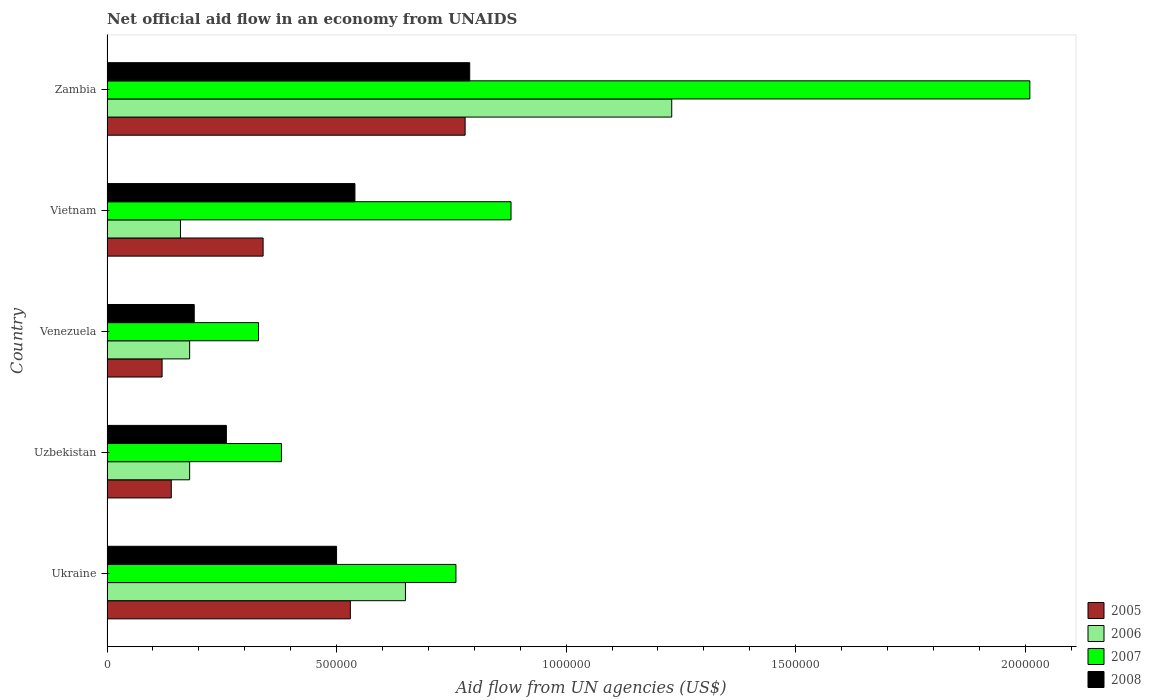How many different coloured bars are there?
Your answer should be very brief. 4. How many bars are there on the 1st tick from the top?
Offer a terse response. 4. How many bars are there on the 4th tick from the bottom?
Offer a terse response. 4. What is the label of the 3rd group of bars from the top?
Your response must be concise. Venezuela. In how many cases, is the number of bars for a given country not equal to the number of legend labels?
Your response must be concise. 0. Across all countries, what is the maximum net official aid flow in 2006?
Provide a succinct answer. 1.23e+06. Across all countries, what is the minimum net official aid flow in 2007?
Provide a short and direct response. 3.30e+05. In which country was the net official aid flow in 2007 maximum?
Make the answer very short. Zambia. In which country was the net official aid flow in 2005 minimum?
Your answer should be compact. Venezuela. What is the total net official aid flow in 2006 in the graph?
Offer a very short reply. 2.40e+06. What is the difference between the net official aid flow in 2008 in Uzbekistan and that in Venezuela?
Your answer should be compact. 7.00e+04. What is the difference between the net official aid flow in 2006 in Zambia and the net official aid flow in 2005 in Vietnam?
Your answer should be compact. 8.90e+05. What is the average net official aid flow in 2007 per country?
Ensure brevity in your answer.  8.72e+05. What is the difference between the net official aid flow in 2006 and net official aid flow in 2008 in Venezuela?
Offer a very short reply. -10000. What is the ratio of the net official aid flow in 2005 in Uzbekistan to that in Venezuela?
Your answer should be very brief. 1.17. Is the net official aid flow in 2005 in Venezuela less than that in Vietnam?
Ensure brevity in your answer.  Yes. What is the difference between the highest and the second highest net official aid flow in 2005?
Your answer should be very brief. 2.50e+05. What is the difference between the highest and the lowest net official aid flow in 2006?
Your answer should be compact. 1.07e+06. Is it the case that in every country, the sum of the net official aid flow in 2005 and net official aid flow in 2008 is greater than the sum of net official aid flow in 2006 and net official aid flow in 2007?
Your response must be concise. No. What does the 2nd bar from the bottom in Venezuela represents?
Keep it short and to the point. 2006. Is it the case that in every country, the sum of the net official aid flow in 2007 and net official aid flow in 2008 is greater than the net official aid flow in 2006?
Keep it short and to the point. Yes. Are all the bars in the graph horizontal?
Provide a succinct answer. Yes. How many countries are there in the graph?
Keep it short and to the point. 5. Are the values on the major ticks of X-axis written in scientific E-notation?
Make the answer very short. No. Where does the legend appear in the graph?
Make the answer very short. Bottom right. How many legend labels are there?
Your response must be concise. 4. How are the legend labels stacked?
Keep it short and to the point. Vertical. What is the title of the graph?
Ensure brevity in your answer.  Net official aid flow in an economy from UNAIDS. What is the label or title of the X-axis?
Keep it short and to the point. Aid flow from UN agencies (US$). What is the label or title of the Y-axis?
Keep it short and to the point. Country. What is the Aid flow from UN agencies (US$) of 2005 in Ukraine?
Your answer should be very brief. 5.30e+05. What is the Aid flow from UN agencies (US$) of 2006 in Ukraine?
Ensure brevity in your answer.  6.50e+05. What is the Aid flow from UN agencies (US$) of 2007 in Ukraine?
Give a very brief answer. 7.60e+05. What is the Aid flow from UN agencies (US$) in 2008 in Ukraine?
Provide a short and direct response. 5.00e+05. What is the Aid flow from UN agencies (US$) of 2005 in Uzbekistan?
Keep it short and to the point. 1.40e+05. What is the Aid flow from UN agencies (US$) of 2006 in Uzbekistan?
Provide a short and direct response. 1.80e+05. What is the Aid flow from UN agencies (US$) of 2008 in Uzbekistan?
Provide a succinct answer. 2.60e+05. What is the Aid flow from UN agencies (US$) in 2008 in Venezuela?
Provide a short and direct response. 1.90e+05. What is the Aid flow from UN agencies (US$) in 2007 in Vietnam?
Provide a short and direct response. 8.80e+05. What is the Aid flow from UN agencies (US$) in 2008 in Vietnam?
Give a very brief answer. 5.40e+05. What is the Aid flow from UN agencies (US$) of 2005 in Zambia?
Your answer should be very brief. 7.80e+05. What is the Aid flow from UN agencies (US$) in 2006 in Zambia?
Your answer should be compact. 1.23e+06. What is the Aid flow from UN agencies (US$) of 2007 in Zambia?
Keep it short and to the point. 2.01e+06. What is the Aid flow from UN agencies (US$) in 2008 in Zambia?
Your answer should be very brief. 7.90e+05. Across all countries, what is the maximum Aid flow from UN agencies (US$) in 2005?
Offer a very short reply. 7.80e+05. Across all countries, what is the maximum Aid flow from UN agencies (US$) of 2006?
Offer a very short reply. 1.23e+06. Across all countries, what is the maximum Aid flow from UN agencies (US$) of 2007?
Provide a short and direct response. 2.01e+06. Across all countries, what is the maximum Aid flow from UN agencies (US$) of 2008?
Offer a very short reply. 7.90e+05. Across all countries, what is the minimum Aid flow from UN agencies (US$) of 2005?
Make the answer very short. 1.20e+05. Across all countries, what is the minimum Aid flow from UN agencies (US$) of 2006?
Offer a terse response. 1.60e+05. Across all countries, what is the minimum Aid flow from UN agencies (US$) in 2007?
Give a very brief answer. 3.30e+05. Across all countries, what is the minimum Aid flow from UN agencies (US$) of 2008?
Your answer should be very brief. 1.90e+05. What is the total Aid flow from UN agencies (US$) in 2005 in the graph?
Your response must be concise. 1.91e+06. What is the total Aid flow from UN agencies (US$) of 2006 in the graph?
Provide a succinct answer. 2.40e+06. What is the total Aid flow from UN agencies (US$) in 2007 in the graph?
Make the answer very short. 4.36e+06. What is the total Aid flow from UN agencies (US$) of 2008 in the graph?
Offer a very short reply. 2.28e+06. What is the difference between the Aid flow from UN agencies (US$) in 2005 in Ukraine and that in Uzbekistan?
Your answer should be very brief. 3.90e+05. What is the difference between the Aid flow from UN agencies (US$) of 2006 in Ukraine and that in Uzbekistan?
Provide a succinct answer. 4.70e+05. What is the difference between the Aid flow from UN agencies (US$) of 2008 in Ukraine and that in Uzbekistan?
Your answer should be very brief. 2.40e+05. What is the difference between the Aid flow from UN agencies (US$) in 2005 in Ukraine and that in Venezuela?
Your answer should be compact. 4.10e+05. What is the difference between the Aid flow from UN agencies (US$) of 2008 in Ukraine and that in Venezuela?
Provide a short and direct response. 3.10e+05. What is the difference between the Aid flow from UN agencies (US$) in 2005 in Ukraine and that in Zambia?
Your answer should be very brief. -2.50e+05. What is the difference between the Aid flow from UN agencies (US$) in 2006 in Ukraine and that in Zambia?
Provide a succinct answer. -5.80e+05. What is the difference between the Aid flow from UN agencies (US$) in 2007 in Ukraine and that in Zambia?
Keep it short and to the point. -1.25e+06. What is the difference between the Aid flow from UN agencies (US$) of 2008 in Ukraine and that in Zambia?
Offer a terse response. -2.90e+05. What is the difference between the Aid flow from UN agencies (US$) in 2006 in Uzbekistan and that in Venezuela?
Offer a terse response. 0. What is the difference between the Aid flow from UN agencies (US$) in 2007 in Uzbekistan and that in Venezuela?
Ensure brevity in your answer.  5.00e+04. What is the difference between the Aid flow from UN agencies (US$) of 2006 in Uzbekistan and that in Vietnam?
Give a very brief answer. 2.00e+04. What is the difference between the Aid flow from UN agencies (US$) in 2007 in Uzbekistan and that in Vietnam?
Provide a succinct answer. -5.00e+05. What is the difference between the Aid flow from UN agencies (US$) in 2008 in Uzbekistan and that in Vietnam?
Your response must be concise. -2.80e+05. What is the difference between the Aid flow from UN agencies (US$) of 2005 in Uzbekistan and that in Zambia?
Give a very brief answer. -6.40e+05. What is the difference between the Aid flow from UN agencies (US$) of 2006 in Uzbekistan and that in Zambia?
Offer a very short reply. -1.05e+06. What is the difference between the Aid flow from UN agencies (US$) in 2007 in Uzbekistan and that in Zambia?
Keep it short and to the point. -1.63e+06. What is the difference between the Aid flow from UN agencies (US$) of 2008 in Uzbekistan and that in Zambia?
Make the answer very short. -5.30e+05. What is the difference between the Aid flow from UN agencies (US$) of 2006 in Venezuela and that in Vietnam?
Make the answer very short. 2.00e+04. What is the difference between the Aid flow from UN agencies (US$) of 2007 in Venezuela and that in Vietnam?
Give a very brief answer. -5.50e+05. What is the difference between the Aid flow from UN agencies (US$) of 2008 in Venezuela and that in Vietnam?
Ensure brevity in your answer.  -3.50e+05. What is the difference between the Aid flow from UN agencies (US$) of 2005 in Venezuela and that in Zambia?
Make the answer very short. -6.60e+05. What is the difference between the Aid flow from UN agencies (US$) in 2006 in Venezuela and that in Zambia?
Your answer should be very brief. -1.05e+06. What is the difference between the Aid flow from UN agencies (US$) in 2007 in Venezuela and that in Zambia?
Your answer should be very brief. -1.68e+06. What is the difference between the Aid flow from UN agencies (US$) of 2008 in Venezuela and that in Zambia?
Your response must be concise. -6.00e+05. What is the difference between the Aid flow from UN agencies (US$) in 2005 in Vietnam and that in Zambia?
Your response must be concise. -4.40e+05. What is the difference between the Aid flow from UN agencies (US$) of 2006 in Vietnam and that in Zambia?
Make the answer very short. -1.07e+06. What is the difference between the Aid flow from UN agencies (US$) in 2007 in Vietnam and that in Zambia?
Provide a short and direct response. -1.13e+06. What is the difference between the Aid flow from UN agencies (US$) in 2005 in Ukraine and the Aid flow from UN agencies (US$) in 2008 in Uzbekistan?
Offer a very short reply. 2.70e+05. What is the difference between the Aid flow from UN agencies (US$) of 2007 in Ukraine and the Aid flow from UN agencies (US$) of 2008 in Uzbekistan?
Offer a terse response. 5.00e+05. What is the difference between the Aid flow from UN agencies (US$) in 2005 in Ukraine and the Aid flow from UN agencies (US$) in 2007 in Venezuela?
Give a very brief answer. 2.00e+05. What is the difference between the Aid flow from UN agencies (US$) in 2006 in Ukraine and the Aid flow from UN agencies (US$) in 2008 in Venezuela?
Provide a short and direct response. 4.60e+05. What is the difference between the Aid flow from UN agencies (US$) in 2007 in Ukraine and the Aid flow from UN agencies (US$) in 2008 in Venezuela?
Offer a terse response. 5.70e+05. What is the difference between the Aid flow from UN agencies (US$) in 2005 in Ukraine and the Aid flow from UN agencies (US$) in 2006 in Vietnam?
Provide a succinct answer. 3.70e+05. What is the difference between the Aid flow from UN agencies (US$) in 2005 in Ukraine and the Aid flow from UN agencies (US$) in 2007 in Vietnam?
Make the answer very short. -3.50e+05. What is the difference between the Aid flow from UN agencies (US$) of 2006 in Ukraine and the Aid flow from UN agencies (US$) of 2008 in Vietnam?
Offer a terse response. 1.10e+05. What is the difference between the Aid flow from UN agencies (US$) in 2005 in Ukraine and the Aid flow from UN agencies (US$) in 2006 in Zambia?
Ensure brevity in your answer.  -7.00e+05. What is the difference between the Aid flow from UN agencies (US$) in 2005 in Ukraine and the Aid flow from UN agencies (US$) in 2007 in Zambia?
Offer a very short reply. -1.48e+06. What is the difference between the Aid flow from UN agencies (US$) in 2006 in Ukraine and the Aid flow from UN agencies (US$) in 2007 in Zambia?
Offer a terse response. -1.36e+06. What is the difference between the Aid flow from UN agencies (US$) of 2007 in Ukraine and the Aid flow from UN agencies (US$) of 2008 in Zambia?
Offer a terse response. -3.00e+04. What is the difference between the Aid flow from UN agencies (US$) in 2005 in Uzbekistan and the Aid flow from UN agencies (US$) in 2006 in Venezuela?
Your response must be concise. -4.00e+04. What is the difference between the Aid flow from UN agencies (US$) in 2006 in Uzbekistan and the Aid flow from UN agencies (US$) in 2007 in Venezuela?
Provide a succinct answer. -1.50e+05. What is the difference between the Aid flow from UN agencies (US$) of 2007 in Uzbekistan and the Aid flow from UN agencies (US$) of 2008 in Venezuela?
Your answer should be compact. 1.90e+05. What is the difference between the Aid flow from UN agencies (US$) of 2005 in Uzbekistan and the Aid flow from UN agencies (US$) of 2006 in Vietnam?
Your response must be concise. -2.00e+04. What is the difference between the Aid flow from UN agencies (US$) of 2005 in Uzbekistan and the Aid flow from UN agencies (US$) of 2007 in Vietnam?
Provide a short and direct response. -7.40e+05. What is the difference between the Aid flow from UN agencies (US$) of 2005 in Uzbekistan and the Aid flow from UN agencies (US$) of 2008 in Vietnam?
Ensure brevity in your answer.  -4.00e+05. What is the difference between the Aid flow from UN agencies (US$) in 2006 in Uzbekistan and the Aid flow from UN agencies (US$) in 2007 in Vietnam?
Your answer should be compact. -7.00e+05. What is the difference between the Aid flow from UN agencies (US$) of 2006 in Uzbekistan and the Aid flow from UN agencies (US$) of 2008 in Vietnam?
Ensure brevity in your answer.  -3.60e+05. What is the difference between the Aid flow from UN agencies (US$) of 2005 in Uzbekistan and the Aid flow from UN agencies (US$) of 2006 in Zambia?
Your response must be concise. -1.09e+06. What is the difference between the Aid flow from UN agencies (US$) of 2005 in Uzbekistan and the Aid flow from UN agencies (US$) of 2007 in Zambia?
Keep it short and to the point. -1.87e+06. What is the difference between the Aid flow from UN agencies (US$) of 2005 in Uzbekistan and the Aid flow from UN agencies (US$) of 2008 in Zambia?
Your response must be concise. -6.50e+05. What is the difference between the Aid flow from UN agencies (US$) of 2006 in Uzbekistan and the Aid flow from UN agencies (US$) of 2007 in Zambia?
Your response must be concise. -1.83e+06. What is the difference between the Aid flow from UN agencies (US$) of 2006 in Uzbekistan and the Aid flow from UN agencies (US$) of 2008 in Zambia?
Your answer should be very brief. -6.10e+05. What is the difference between the Aid flow from UN agencies (US$) in 2007 in Uzbekistan and the Aid flow from UN agencies (US$) in 2008 in Zambia?
Your answer should be very brief. -4.10e+05. What is the difference between the Aid flow from UN agencies (US$) in 2005 in Venezuela and the Aid flow from UN agencies (US$) in 2006 in Vietnam?
Your response must be concise. -4.00e+04. What is the difference between the Aid flow from UN agencies (US$) of 2005 in Venezuela and the Aid flow from UN agencies (US$) of 2007 in Vietnam?
Keep it short and to the point. -7.60e+05. What is the difference between the Aid flow from UN agencies (US$) in 2005 in Venezuela and the Aid flow from UN agencies (US$) in 2008 in Vietnam?
Your answer should be very brief. -4.20e+05. What is the difference between the Aid flow from UN agencies (US$) of 2006 in Venezuela and the Aid flow from UN agencies (US$) of 2007 in Vietnam?
Give a very brief answer. -7.00e+05. What is the difference between the Aid flow from UN agencies (US$) in 2006 in Venezuela and the Aid flow from UN agencies (US$) in 2008 in Vietnam?
Your response must be concise. -3.60e+05. What is the difference between the Aid flow from UN agencies (US$) in 2007 in Venezuela and the Aid flow from UN agencies (US$) in 2008 in Vietnam?
Provide a short and direct response. -2.10e+05. What is the difference between the Aid flow from UN agencies (US$) in 2005 in Venezuela and the Aid flow from UN agencies (US$) in 2006 in Zambia?
Offer a very short reply. -1.11e+06. What is the difference between the Aid flow from UN agencies (US$) in 2005 in Venezuela and the Aid flow from UN agencies (US$) in 2007 in Zambia?
Keep it short and to the point. -1.89e+06. What is the difference between the Aid flow from UN agencies (US$) of 2005 in Venezuela and the Aid flow from UN agencies (US$) of 2008 in Zambia?
Offer a terse response. -6.70e+05. What is the difference between the Aid flow from UN agencies (US$) of 2006 in Venezuela and the Aid flow from UN agencies (US$) of 2007 in Zambia?
Keep it short and to the point. -1.83e+06. What is the difference between the Aid flow from UN agencies (US$) of 2006 in Venezuela and the Aid flow from UN agencies (US$) of 2008 in Zambia?
Your answer should be compact. -6.10e+05. What is the difference between the Aid flow from UN agencies (US$) of 2007 in Venezuela and the Aid flow from UN agencies (US$) of 2008 in Zambia?
Ensure brevity in your answer.  -4.60e+05. What is the difference between the Aid flow from UN agencies (US$) of 2005 in Vietnam and the Aid flow from UN agencies (US$) of 2006 in Zambia?
Your response must be concise. -8.90e+05. What is the difference between the Aid flow from UN agencies (US$) in 2005 in Vietnam and the Aid flow from UN agencies (US$) in 2007 in Zambia?
Your response must be concise. -1.67e+06. What is the difference between the Aid flow from UN agencies (US$) of 2005 in Vietnam and the Aid flow from UN agencies (US$) of 2008 in Zambia?
Give a very brief answer. -4.50e+05. What is the difference between the Aid flow from UN agencies (US$) of 2006 in Vietnam and the Aid flow from UN agencies (US$) of 2007 in Zambia?
Provide a succinct answer. -1.85e+06. What is the difference between the Aid flow from UN agencies (US$) in 2006 in Vietnam and the Aid flow from UN agencies (US$) in 2008 in Zambia?
Give a very brief answer. -6.30e+05. What is the average Aid flow from UN agencies (US$) of 2005 per country?
Keep it short and to the point. 3.82e+05. What is the average Aid flow from UN agencies (US$) of 2006 per country?
Offer a very short reply. 4.80e+05. What is the average Aid flow from UN agencies (US$) of 2007 per country?
Keep it short and to the point. 8.72e+05. What is the average Aid flow from UN agencies (US$) in 2008 per country?
Your answer should be compact. 4.56e+05. What is the difference between the Aid flow from UN agencies (US$) in 2006 and Aid flow from UN agencies (US$) in 2007 in Ukraine?
Your answer should be compact. -1.10e+05. What is the difference between the Aid flow from UN agencies (US$) in 2006 and Aid flow from UN agencies (US$) in 2008 in Ukraine?
Provide a succinct answer. 1.50e+05. What is the difference between the Aid flow from UN agencies (US$) in 2007 and Aid flow from UN agencies (US$) in 2008 in Ukraine?
Offer a very short reply. 2.60e+05. What is the difference between the Aid flow from UN agencies (US$) of 2005 and Aid flow from UN agencies (US$) of 2006 in Uzbekistan?
Provide a succinct answer. -4.00e+04. What is the difference between the Aid flow from UN agencies (US$) in 2005 and Aid flow from UN agencies (US$) in 2007 in Uzbekistan?
Give a very brief answer. -2.40e+05. What is the difference between the Aid flow from UN agencies (US$) of 2006 and Aid flow from UN agencies (US$) of 2007 in Uzbekistan?
Keep it short and to the point. -2.00e+05. What is the difference between the Aid flow from UN agencies (US$) of 2005 and Aid flow from UN agencies (US$) of 2008 in Venezuela?
Ensure brevity in your answer.  -7.00e+04. What is the difference between the Aid flow from UN agencies (US$) of 2005 and Aid flow from UN agencies (US$) of 2006 in Vietnam?
Give a very brief answer. 1.80e+05. What is the difference between the Aid flow from UN agencies (US$) of 2005 and Aid flow from UN agencies (US$) of 2007 in Vietnam?
Give a very brief answer. -5.40e+05. What is the difference between the Aid flow from UN agencies (US$) of 2006 and Aid flow from UN agencies (US$) of 2007 in Vietnam?
Provide a short and direct response. -7.20e+05. What is the difference between the Aid flow from UN agencies (US$) in 2006 and Aid flow from UN agencies (US$) in 2008 in Vietnam?
Provide a succinct answer. -3.80e+05. What is the difference between the Aid flow from UN agencies (US$) of 2007 and Aid flow from UN agencies (US$) of 2008 in Vietnam?
Ensure brevity in your answer.  3.40e+05. What is the difference between the Aid flow from UN agencies (US$) in 2005 and Aid flow from UN agencies (US$) in 2006 in Zambia?
Your answer should be compact. -4.50e+05. What is the difference between the Aid flow from UN agencies (US$) in 2005 and Aid flow from UN agencies (US$) in 2007 in Zambia?
Your answer should be very brief. -1.23e+06. What is the difference between the Aid flow from UN agencies (US$) in 2006 and Aid flow from UN agencies (US$) in 2007 in Zambia?
Provide a short and direct response. -7.80e+05. What is the difference between the Aid flow from UN agencies (US$) of 2006 and Aid flow from UN agencies (US$) of 2008 in Zambia?
Keep it short and to the point. 4.40e+05. What is the difference between the Aid flow from UN agencies (US$) in 2007 and Aid flow from UN agencies (US$) in 2008 in Zambia?
Provide a succinct answer. 1.22e+06. What is the ratio of the Aid flow from UN agencies (US$) of 2005 in Ukraine to that in Uzbekistan?
Make the answer very short. 3.79. What is the ratio of the Aid flow from UN agencies (US$) of 2006 in Ukraine to that in Uzbekistan?
Keep it short and to the point. 3.61. What is the ratio of the Aid flow from UN agencies (US$) of 2007 in Ukraine to that in Uzbekistan?
Make the answer very short. 2. What is the ratio of the Aid flow from UN agencies (US$) in 2008 in Ukraine to that in Uzbekistan?
Your response must be concise. 1.92. What is the ratio of the Aid flow from UN agencies (US$) in 2005 in Ukraine to that in Venezuela?
Offer a terse response. 4.42. What is the ratio of the Aid flow from UN agencies (US$) of 2006 in Ukraine to that in Venezuela?
Your answer should be compact. 3.61. What is the ratio of the Aid flow from UN agencies (US$) in 2007 in Ukraine to that in Venezuela?
Provide a succinct answer. 2.3. What is the ratio of the Aid flow from UN agencies (US$) of 2008 in Ukraine to that in Venezuela?
Provide a succinct answer. 2.63. What is the ratio of the Aid flow from UN agencies (US$) of 2005 in Ukraine to that in Vietnam?
Offer a very short reply. 1.56. What is the ratio of the Aid flow from UN agencies (US$) of 2006 in Ukraine to that in Vietnam?
Your answer should be very brief. 4.06. What is the ratio of the Aid flow from UN agencies (US$) in 2007 in Ukraine to that in Vietnam?
Offer a terse response. 0.86. What is the ratio of the Aid flow from UN agencies (US$) in 2008 in Ukraine to that in Vietnam?
Make the answer very short. 0.93. What is the ratio of the Aid flow from UN agencies (US$) of 2005 in Ukraine to that in Zambia?
Your answer should be very brief. 0.68. What is the ratio of the Aid flow from UN agencies (US$) in 2006 in Ukraine to that in Zambia?
Give a very brief answer. 0.53. What is the ratio of the Aid flow from UN agencies (US$) of 2007 in Ukraine to that in Zambia?
Keep it short and to the point. 0.38. What is the ratio of the Aid flow from UN agencies (US$) in 2008 in Ukraine to that in Zambia?
Ensure brevity in your answer.  0.63. What is the ratio of the Aid flow from UN agencies (US$) of 2006 in Uzbekistan to that in Venezuela?
Offer a terse response. 1. What is the ratio of the Aid flow from UN agencies (US$) in 2007 in Uzbekistan to that in Venezuela?
Offer a terse response. 1.15. What is the ratio of the Aid flow from UN agencies (US$) of 2008 in Uzbekistan to that in Venezuela?
Ensure brevity in your answer.  1.37. What is the ratio of the Aid flow from UN agencies (US$) of 2005 in Uzbekistan to that in Vietnam?
Your answer should be very brief. 0.41. What is the ratio of the Aid flow from UN agencies (US$) in 2006 in Uzbekistan to that in Vietnam?
Your answer should be compact. 1.12. What is the ratio of the Aid flow from UN agencies (US$) of 2007 in Uzbekistan to that in Vietnam?
Your response must be concise. 0.43. What is the ratio of the Aid flow from UN agencies (US$) of 2008 in Uzbekistan to that in Vietnam?
Provide a short and direct response. 0.48. What is the ratio of the Aid flow from UN agencies (US$) in 2005 in Uzbekistan to that in Zambia?
Provide a short and direct response. 0.18. What is the ratio of the Aid flow from UN agencies (US$) of 2006 in Uzbekistan to that in Zambia?
Keep it short and to the point. 0.15. What is the ratio of the Aid flow from UN agencies (US$) of 2007 in Uzbekistan to that in Zambia?
Make the answer very short. 0.19. What is the ratio of the Aid flow from UN agencies (US$) of 2008 in Uzbekistan to that in Zambia?
Your answer should be very brief. 0.33. What is the ratio of the Aid flow from UN agencies (US$) in 2005 in Venezuela to that in Vietnam?
Your response must be concise. 0.35. What is the ratio of the Aid flow from UN agencies (US$) of 2008 in Venezuela to that in Vietnam?
Ensure brevity in your answer.  0.35. What is the ratio of the Aid flow from UN agencies (US$) in 2005 in Venezuela to that in Zambia?
Offer a very short reply. 0.15. What is the ratio of the Aid flow from UN agencies (US$) of 2006 in Venezuela to that in Zambia?
Provide a succinct answer. 0.15. What is the ratio of the Aid flow from UN agencies (US$) of 2007 in Venezuela to that in Zambia?
Make the answer very short. 0.16. What is the ratio of the Aid flow from UN agencies (US$) in 2008 in Venezuela to that in Zambia?
Provide a succinct answer. 0.24. What is the ratio of the Aid flow from UN agencies (US$) of 2005 in Vietnam to that in Zambia?
Provide a succinct answer. 0.44. What is the ratio of the Aid flow from UN agencies (US$) of 2006 in Vietnam to that in Zambia?
Your response must be concise. 0.13. What is the ratio of the Aid flow from UN agencies (US$) in 2007 in Vietnam to that in Zambia?
Your response must be concise. 0.44. What is the ratio of the Aid flow from UN agencies (US$) in 2008 in Vietnam to that in Zambia?
Keep it short and to the point. 0.68. What is the difference between the highest and the second highest Aid flow from UN agencies (US$) of 2006?
Offer a terse response. 5.80e+05. What is the difference between the highest and the second highest Aid flow from UN agencies (US$) in 2007?
Ensure brevity in your answer.  1.13e+06. What is the difference between the highest and the second highest Aid flow from UN agencies (US$) of 2008?
Your response must be concise. 2.50e+05. What is the difference between the highest and the lowest Aid flow from UN agencies (US$) of 2006?
Your answer should be very brief. 1.07e+06. What is the difference between the highest and the lowest Aid flow from UN agencies (US$) of 2007?
Offer a very short reply. 1.68e+06. 